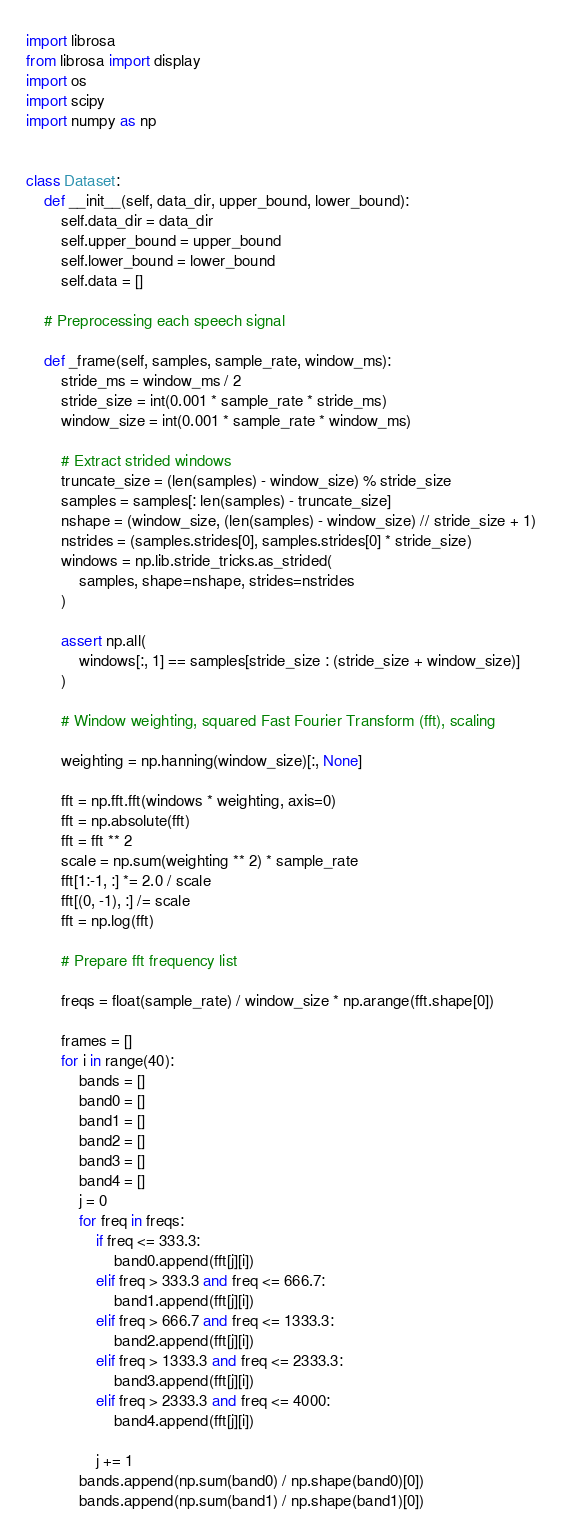Convert code to text. <code><loc_0><loc_0><loc_500><loc_500><_Python_>import librosa
from librosa import display
import os
import scipy
import numpy as np


class Dataset:
    def __init__(self, data_dir, upper_bound, lower_bound):
        self.data_dir = data_dir
        self.upper_bound = upper_bound
        self.lower_bound = lower_bound
        self.data = []

    # Preprocessing each speech signal

    def _frame(self, samples, sample_rate, window_ms):
        stride_ms = window_ms / 2
        stride_size = int(0.001 * sample_rate * stride_ms)
        window_size = int(0.001 * sample_rate * window_ms)

        # Extract strided windows
        truncate_size = (len(samples) - window_size) % stride_size
        samples = samples[: len(samples) - truncate_size]
        nshape = (window_size, (len(samples) - window_size) // stride_size + 1)
        nstrides = (samples.strides[0], samples.strides[0] * stride_size)
        windows = np.lib.stride_tricks.as_strided(
            samples, shape=nshape, strides=nstrides
        )

        assert np.all(
            windows[:, 1] == samples[stride_size : (stride_size + window_size)]
        )

        # Window weighting, squared Fast Fourier Transform (fft), scaling

        weighting = np.hanning(window_size)[:, None]

        fft = np.fft.fft(windows * weighting, axis=0)
        fft = np.absolute(fft)
        fft = fft ** 2
        scale = np.sum(weighting ** 2) * sample_rate
        fft[1:-1, :] *= 2.0 / scale
        fft[(0, -1), :] /= scale
        fft = np.log(fft)

        # Prepare fft frequency list

        freqs = float(sample_rate) / window_size * np.arange(fft.shape[0])

        frames = []
        for i in range(40):
            bands = []
            band0 = []
            band1 = []
            band2 = []
            band3 = []
            band4 = []
            j = 0
            for freq in freqs:
                if freq <= 333.3:
                    band0.append(fft[j][i])
                elif freq > 333.3 and freq <= 666.7:
                    band1.append(fft[j][i])
                elif freq > 666.7 and freq <= 1333.3:
                    band2.append(fft[j][i])
                elif freq > 1333.3 and freq <= 2333.3:
                    band3.append(fft[j][i])
                elif freq > 2333.3 and freq <= 4000:
                    band4.append(fft[j][i])

                j += 1
            bands.append(np.sum(band0) / np.shape(band0)[0])
            bands.append(np.sum(band1) / np.shape(band1)[0])</code> 